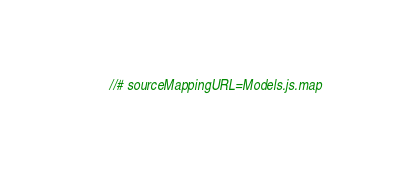<code> <loc_0><loc_0><loc_500><loc_500><_JavaScript_>//# sourceMappingURL=Models.js.map</code> 